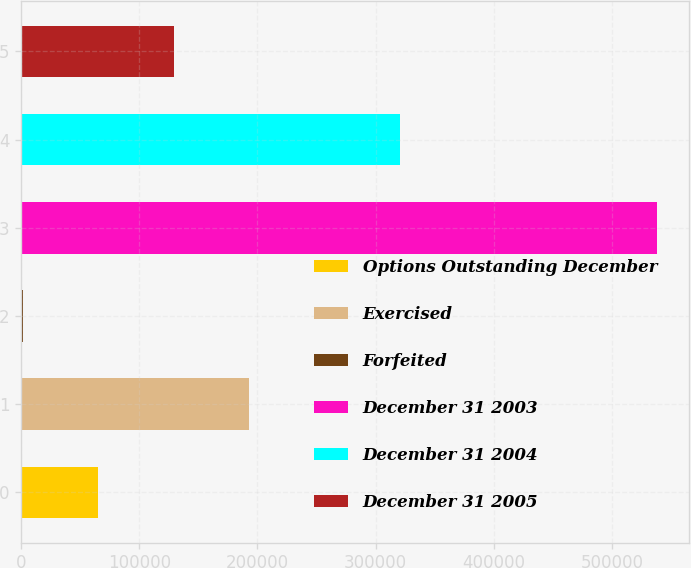<chart> <loc_0><loc_0><loc_500><loc_500><bar_chart><fcel>Options Outstanding December<fcel>Exercised<fcel>Forfeited<fcel>December 31 2003<fcel>December 31 2004<fcel>December 31 2005<nl><fcel>65202.6<fcel>193048<fcel>1280<fcel>537885<fcel>320893<fcel>129125<nl></chart> 